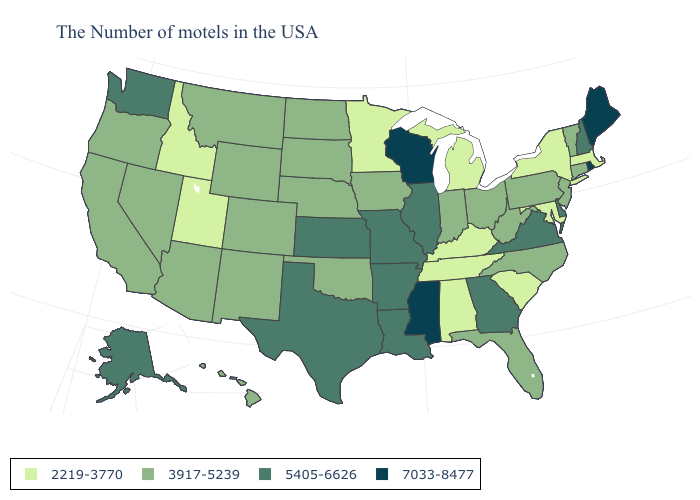Does Wisconsin have the highest value in the MidWest?
Answer briefly. Yes. Name the states that have a value in the range 3917-5239?
Write a very short answer. Vermont, Connecticut, New Jersey, Pennsylvania, North Carolina, West Virginia, Ohio, Florida, Indiana, Iowa, Nebraska, Oklahoma, South Dakota, North Dakota, Wyoming, Colorado, New Mexico, Montana, Arizona, Nevada, California, Oregon, Hawaii. Name the states that have a value in the range 5405-6626?
Write a very short answer. New Hampshire, Delaware, Virginia, Georgia, Illinois, Louisiana, Missouri, Arkansas, Kansas, Texas, Washington, Alaska. Name the states that have a value in the range 7033-8477?
Write a very short answer. Maine, Rhode Island, Wisconsin, Mississippi. Which states hav the highest value in the Northeast?
Be succinct. Maine, Rhode Island. What is the value of New York?
Answer briefly. 2219-3770. Name the states that have a value in the range 7033-8477?
Be succinct. Maine, Rhode Island, Wisconsin, Mississippi. What is the value of Connecticut?
Short answer required. 3917-5239. Does the map have missing data?
Give a very brief answer. No. What is the value of New Hampshire?
Short answer required. 5405-6626. Name the states that have a value in the range 5405-6626?
Quick response, please. New Hampshire, Delaware, Virginia, Georgia, Illinois, Louisiana, Missouri, Arkansas, Kansas, Texas, Washington, Alaska. What is the lowest value in states that border Michigan?
Be succinct. 3917-5239. What is the lowest value in the USA?
Write a very short answer. 2219-3770. What is the value of Colorado?
Concise answer only. 3917-5239. 